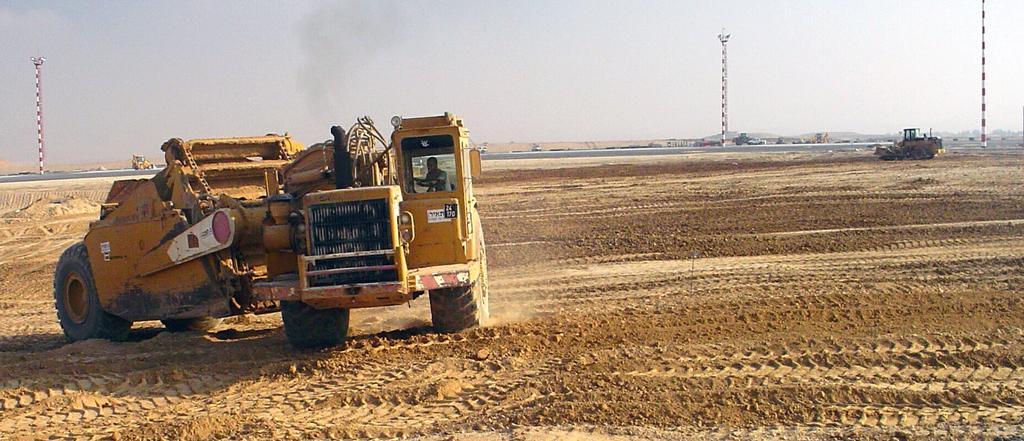How would you summarize this image in a sentence or two? This is an outside view. On the left side, I can see a bulldozer on the ground. In the background, I can see two more bulldozers. One is on the right side and another is on the left side. In the background there is a road and I can see few other vehicles and also I can see few poles. On the top of the image I can see the sky. 